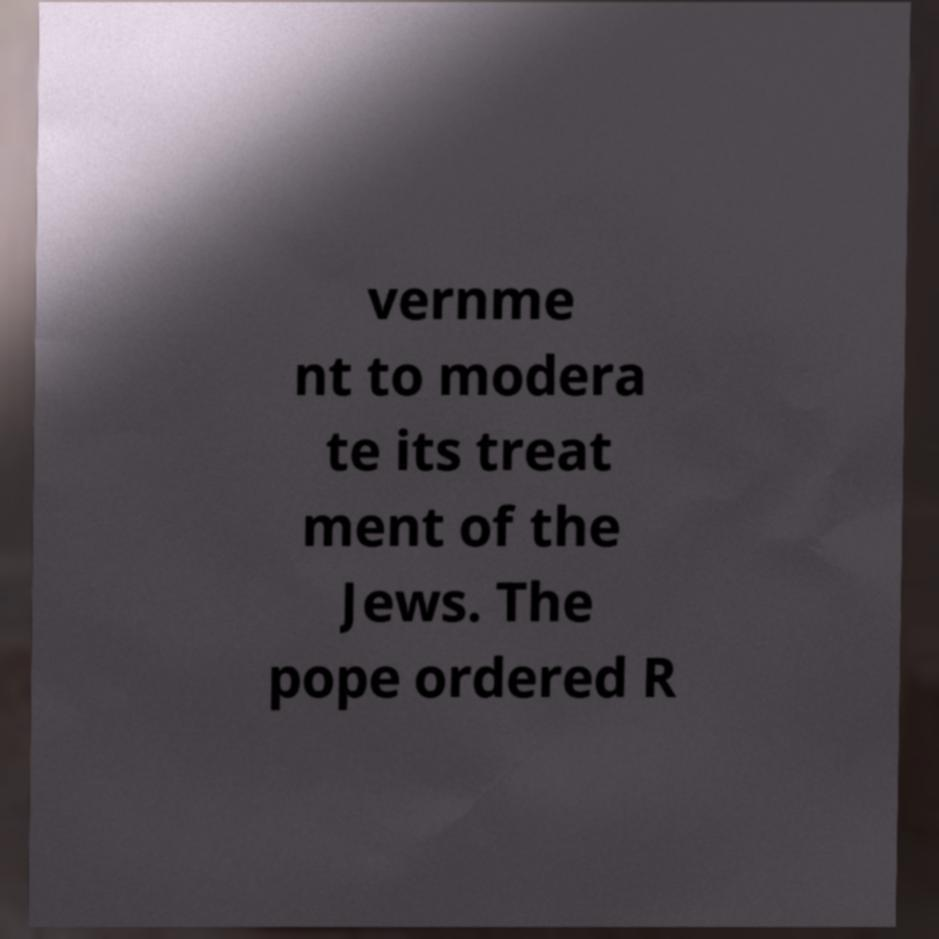Please identify and transcribe the text found in this image. vernme nt to modera te its treat ment of the Jews. The pope ordered R 